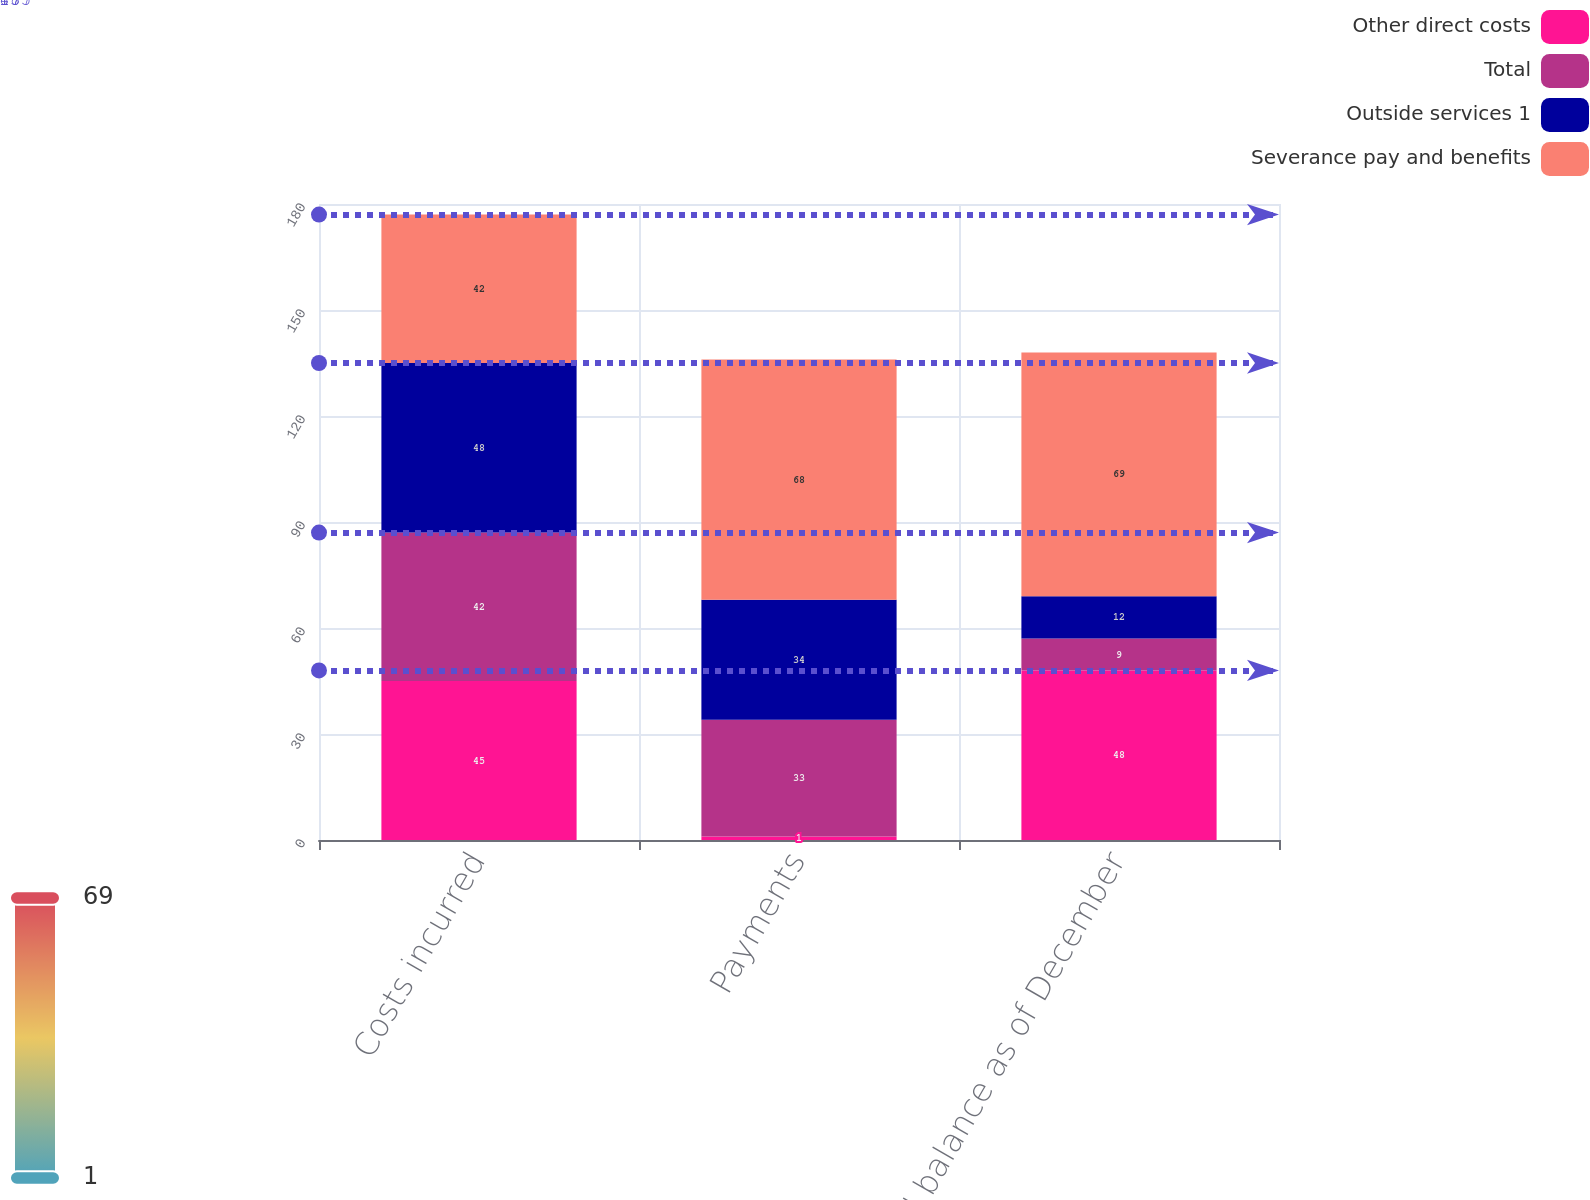<chart> <loc_0><loc_0><loc_500><loc_500><stacked_bar_chart><ecel><fcel>Costs incurred<fcel>Payments<fcel>Accrued balance as of December<nl><fcel>Other direct costs<fcel>45<fcel>1<fcel>48<nl><fcel>Total<fcel>42<fcel>33<fcel>9<nl><fcel>Outside services 1<fcel>48<fcel>34<fcel>12<nl><fcel>Severance pay and benefits<fcel>42<fcel>68<fcel>69<nl></chart> 